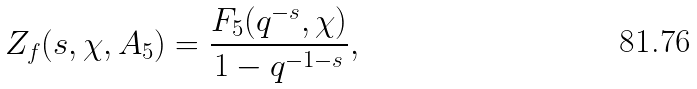Convert formula to latex. <formula><loc_0><loc_0><loc_500><loc_500>Z _ { f } ( s , \chi , A _ { 5 } ) = \frac { F _ { 5 } ( q ^ { - s } , \chi ) } { 1 - q ^ { - 1 - s } } ,</formula> 